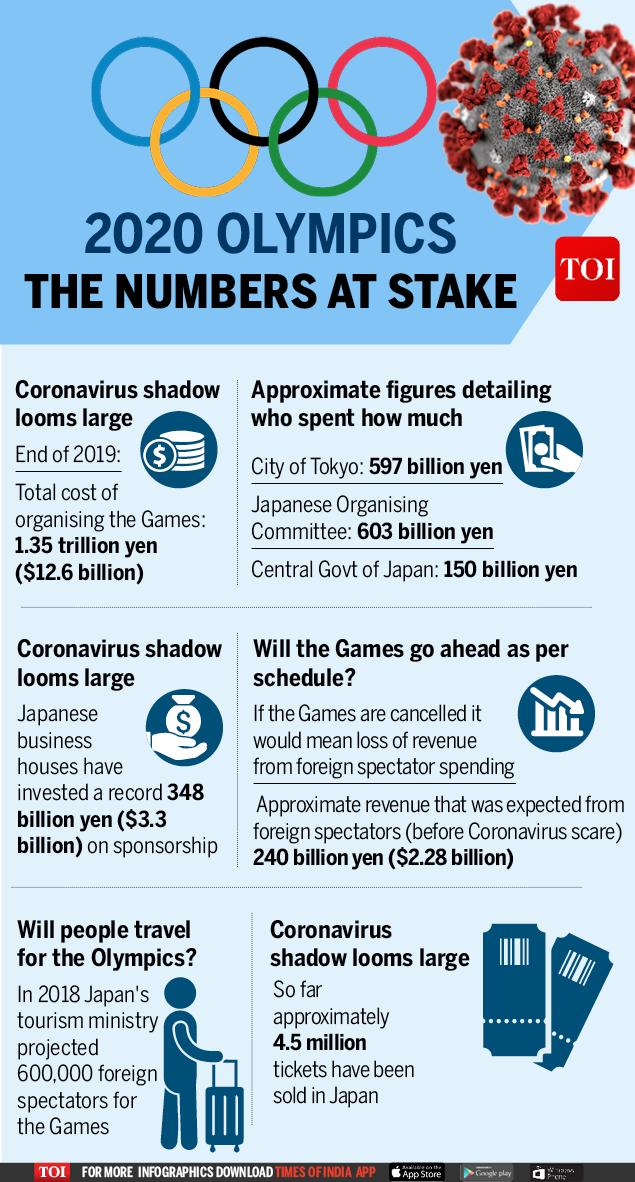Highlight a few significant elements in this photo. The total cost of organizing the games is 348 billion yen. The investment by Japanese business houses is estimated to be approximately $3.3 billion. The findings of the 2020 Olympics, including the numbers involved, have been published by the Times of India news channel. The total cost of organizing the games is approximately $12.6 billion. There are 5 rings in the Olympic logo. 